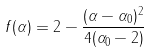Convert formula to latex. <formula><loc_0><loc_0><loc_500><loc_500>f ( \alpha ) = 2 - \frac { ( \alpha - \alpha _ { 0 } ) ^ { 2 } } { 4 ( \alpha _ { 0 } - 2 ) }</formula> 